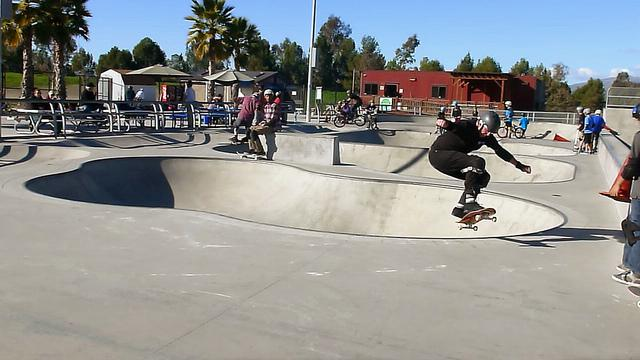Where are the skaters located? Please explain your reasoning. park. The skaters are at an outdoor skate park. 